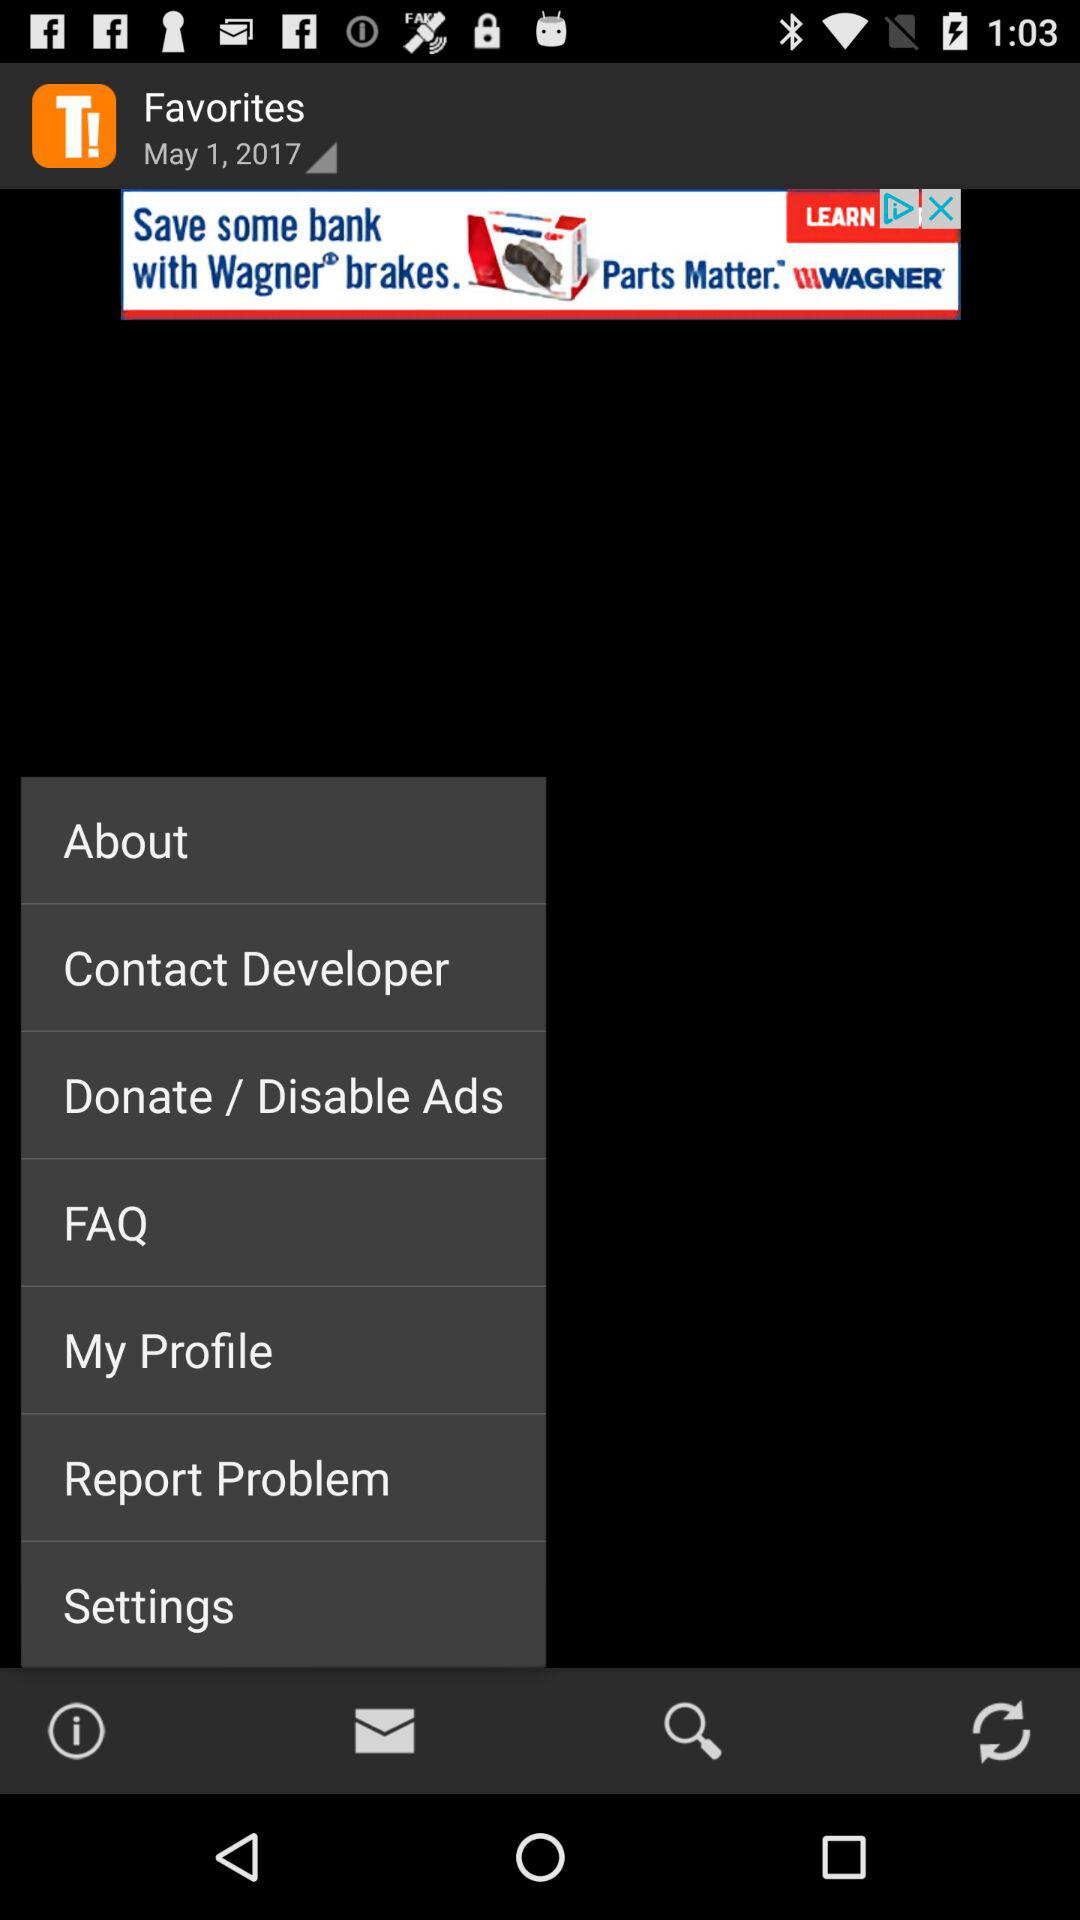What is the selected date? The selected date is May 1, 2017. 